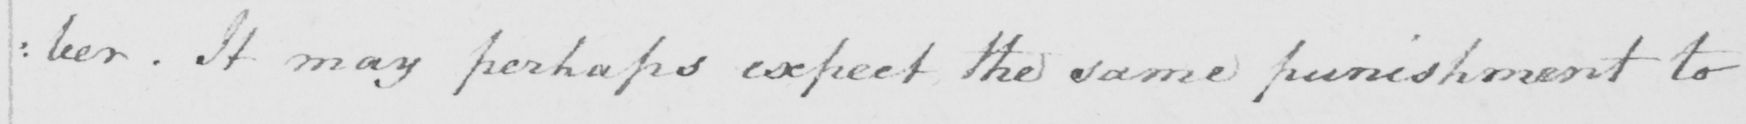Can you read and transcribe this handwriting? :ber. It may perhaps expect the same punishment to 